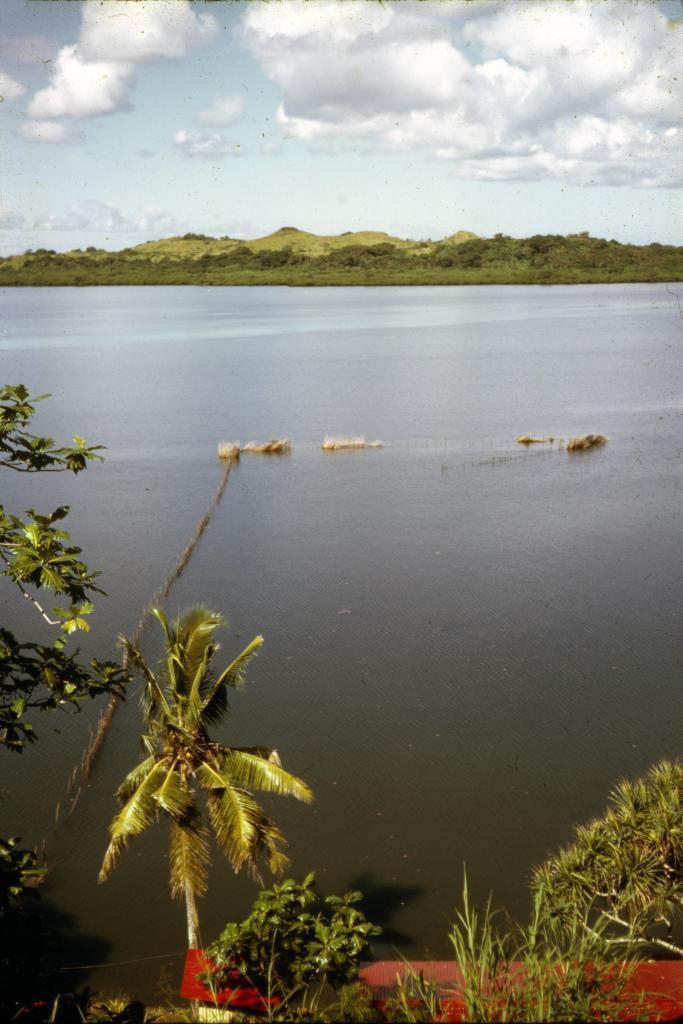Describe this image in one or two sentences. In this image we can see trees, there is the water, there is grass, the sky is cloudy. 